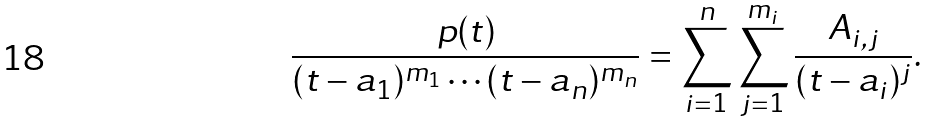<formula> <loc_0><loc_0><loc_500><loc_500>\frac { p ( t ) } { ( t - a _ { 1 } ) ^ { m _ { 1 } } \cdots ( t - a _ { n } ) ^ { m _ { n } } } = \sum _ { i = 1 } ^ { n } \sum _ { j = 1 } ^ { m _ { i } } \frac { A _ { i , j } } { ( t - a _ { i } ) ^ { j } } .</formula> 